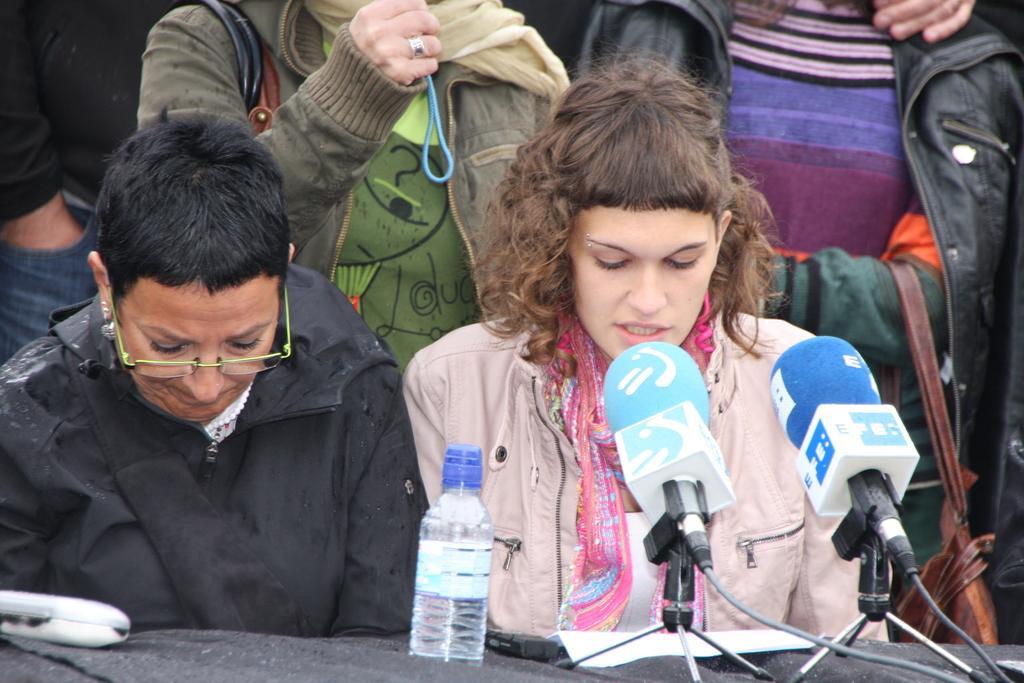Describe this image in one or two sentences. In this picture there is a girl wearing pink color jacket, she is sitting and giving a speech in the microphones. Beside there is an old woman wearing black jackets sitting beside her. In the background there are two girls are standing. 